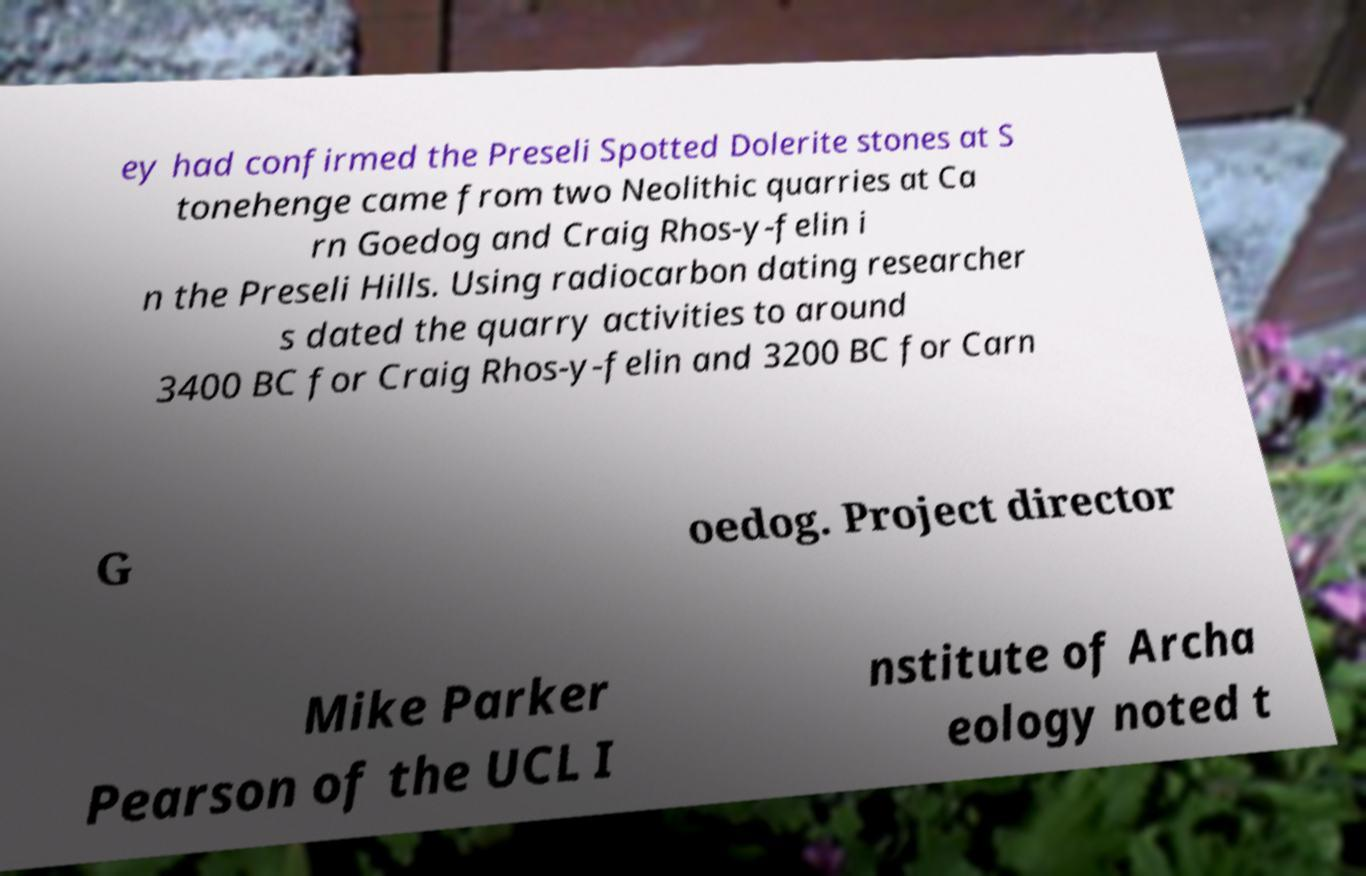Can you accurately transcribe the text from the provided image for me? ey had confirmed the Preseli Spotted Dolerite stones at S tonehenge came from two Neolithic quarries at Ca rn Goedog and Craig Rhos-y-felin i n the Preseli Hills. Using radiocarbon dating researcher s dated the quarry activities to around 3400 BC for Craig Rhos-y-felin and 3200 BC for Carn G oedog. Project director Mike Parker Pearson of the UCL I nstitute of Archa eology noted t 